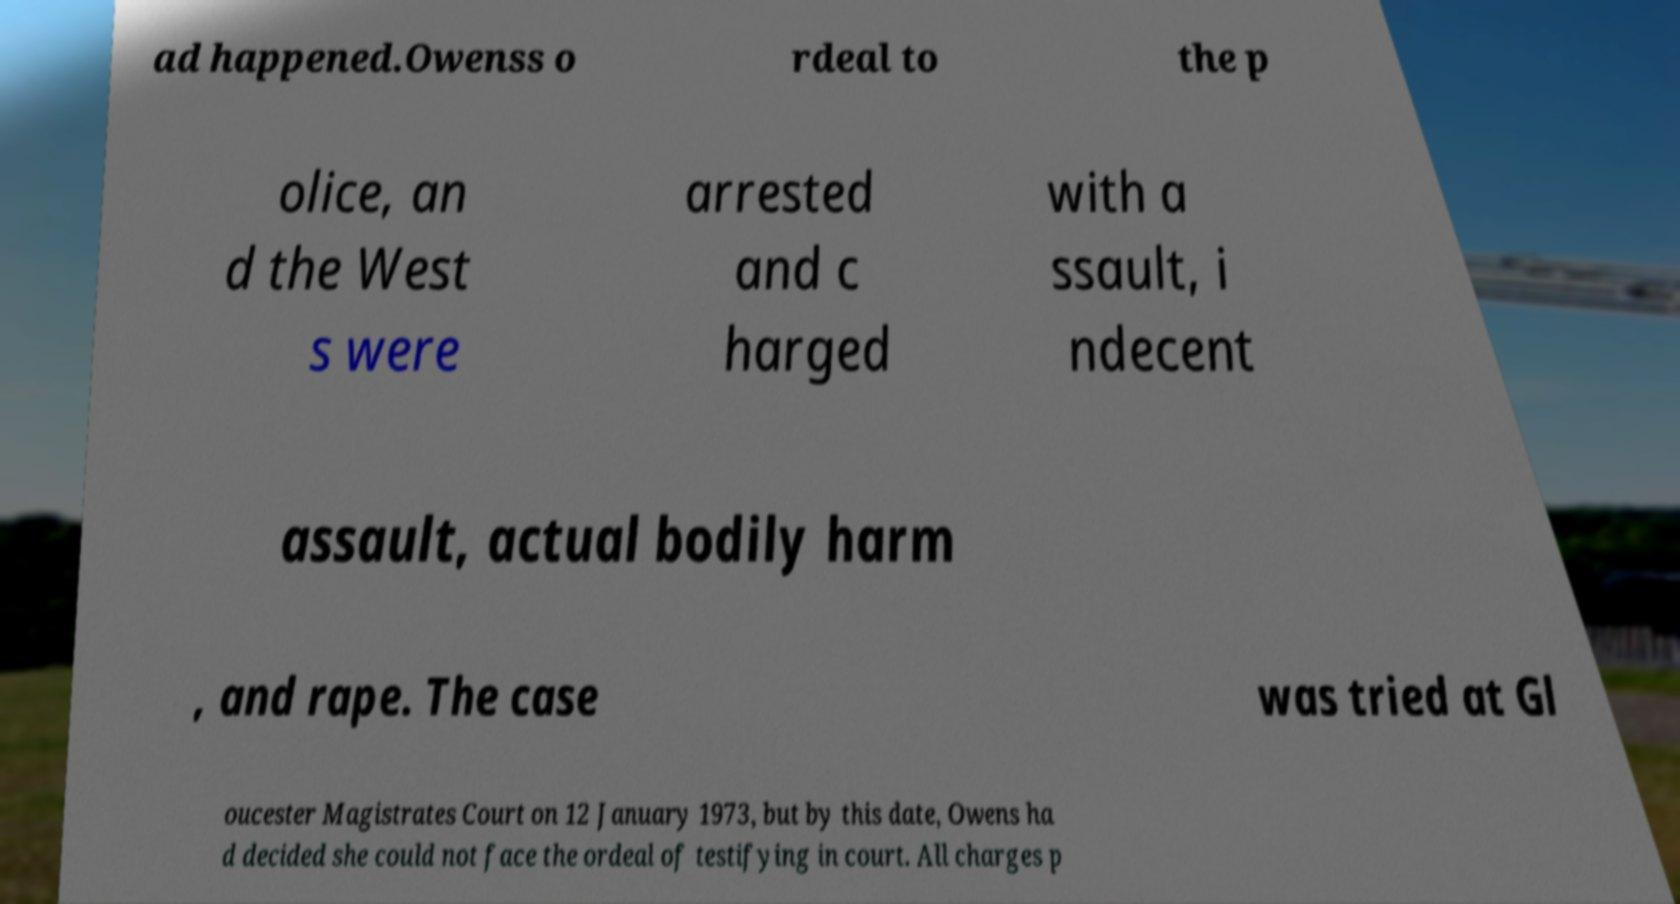Please read and relay the text visible in this image. What does it say? ad happened.Owenss o rdeal to the p olice, an d the West s were arrested and c harged with a ssault, i ndecent assault, actual bodily harm , and rape. The case was tried at Gl oucester Magistrates Court on 12 January 1973, but by this date, Owens ha d decided she could not face the ordeal of testifying in court. All charges p 